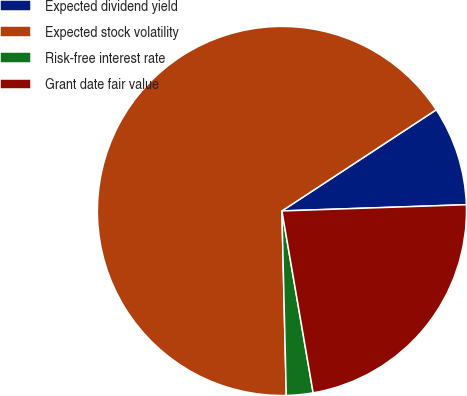Convert chart. <chart><loc_0><loc_0><loc_500><loc_500><pie_chart><fcel>Expected dividend yield<fcel>Expected stock volatility<fcel>Risk-free interest rate<fcel>Grant date fair value<nl><fcel>8.7%<fcel>66.14%<fcel>2.33%<fcel>22.83%<nl></chart> 